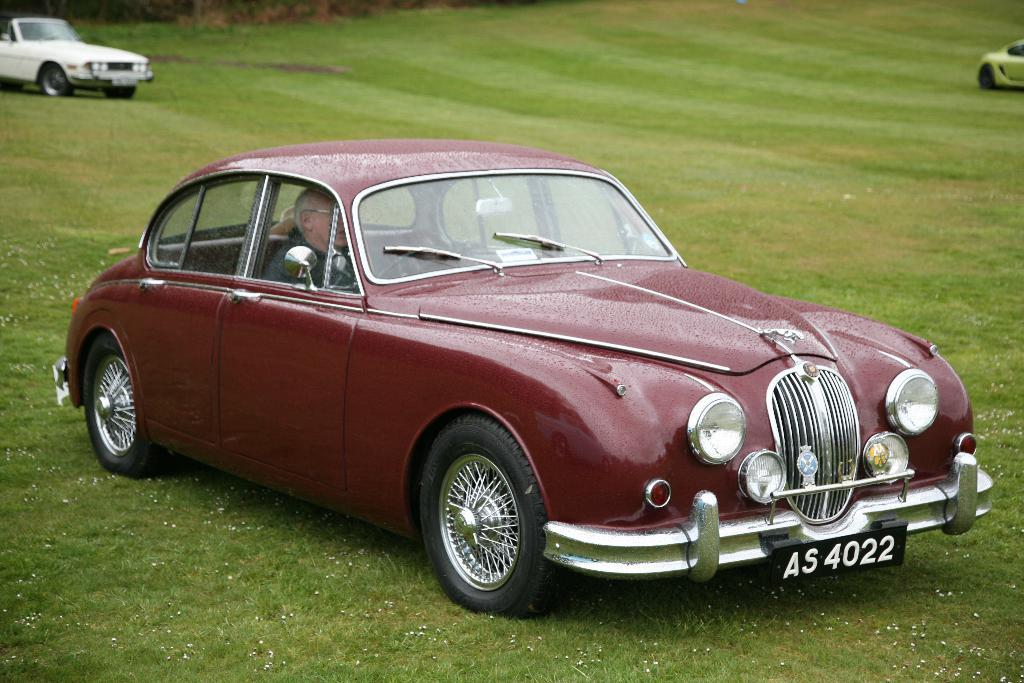What is the main subject of the image? There is a person in a car in the image. Can you describe the location of the vehicles in the image? There are vehicles on the grass in the image. What type of fowl can be seen interacting with the person in the car? There is no fowl present in the image; it only features a person in a car and vehicles on the grass. What emotion is the person in the car displaying in the image? The image does not provide any information about the person's emotions, such as anger. 